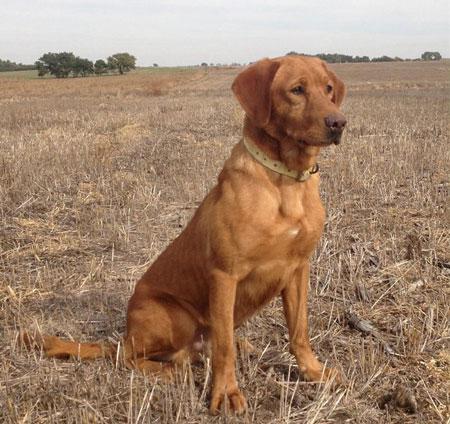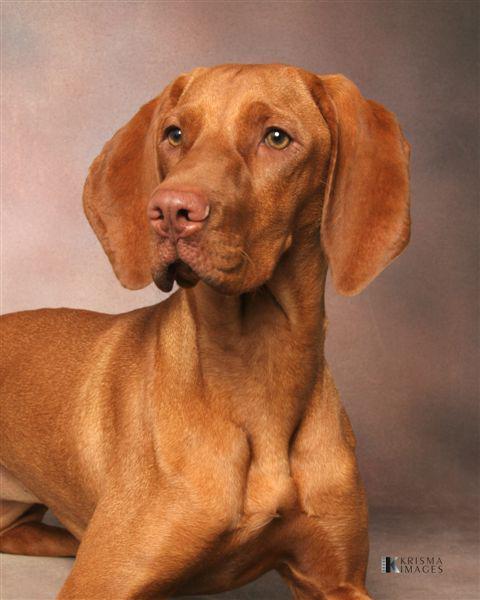The first image is the image on the left, the second image is the image on the right. Given the left and right images, does the statement "Each image contains a single dog with floppy ears, and one image shows a dog outdoors in a non-reclining pose with its head and body angled rightward." hold true? Answer yes or no. Yes. The first image is the image on the left, the second image is the image on the right. Evaluate the accuracy of this statement regarding the images: "The one dog in each image is wearing a collar.". Is it true? Answer yes or no. No. 